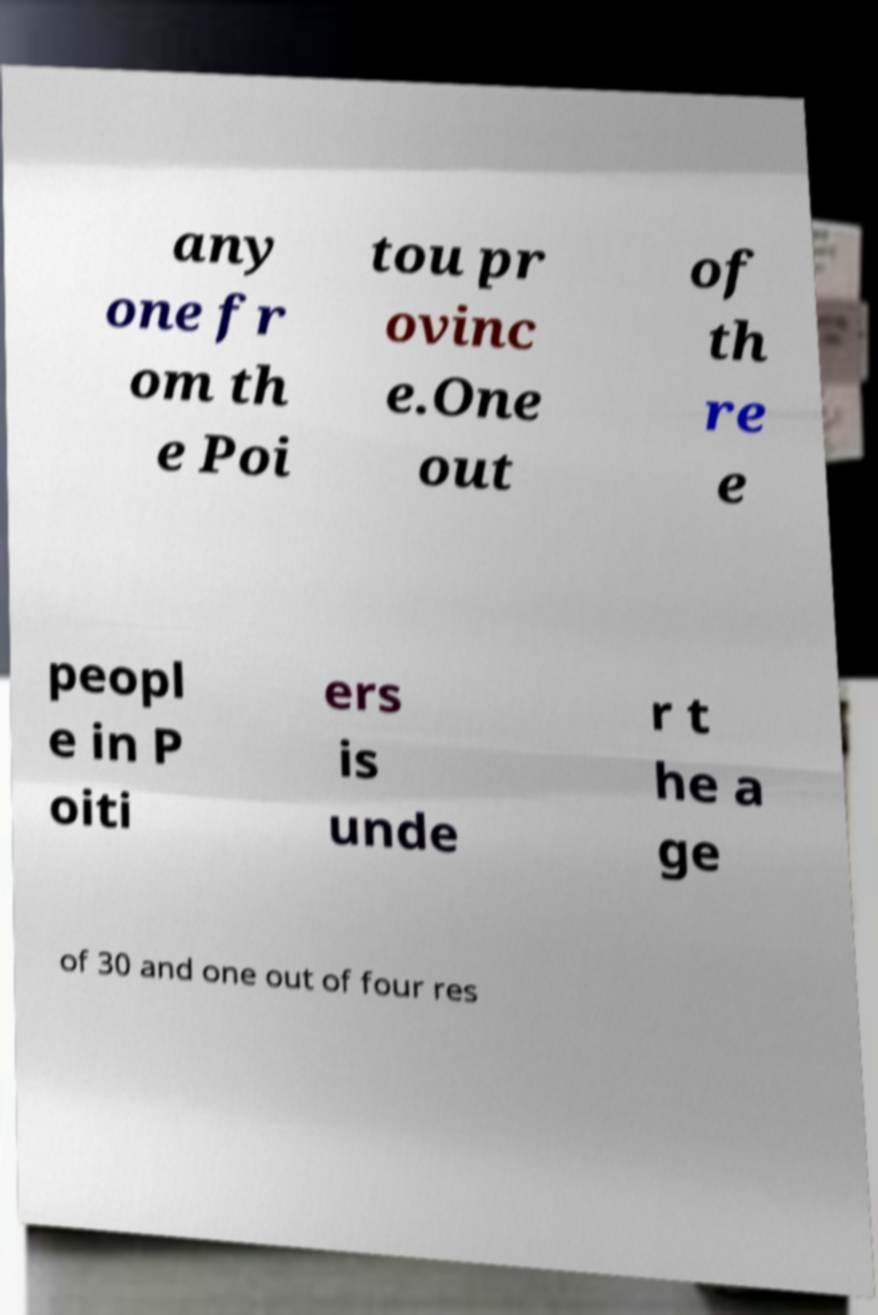Could you extract and type out the text from this image? any one fr om th e Poi tou pr ovinc e.One out of th re e peopl e in P oiti ers is unde r t he a ge of 30 and one out of four res 